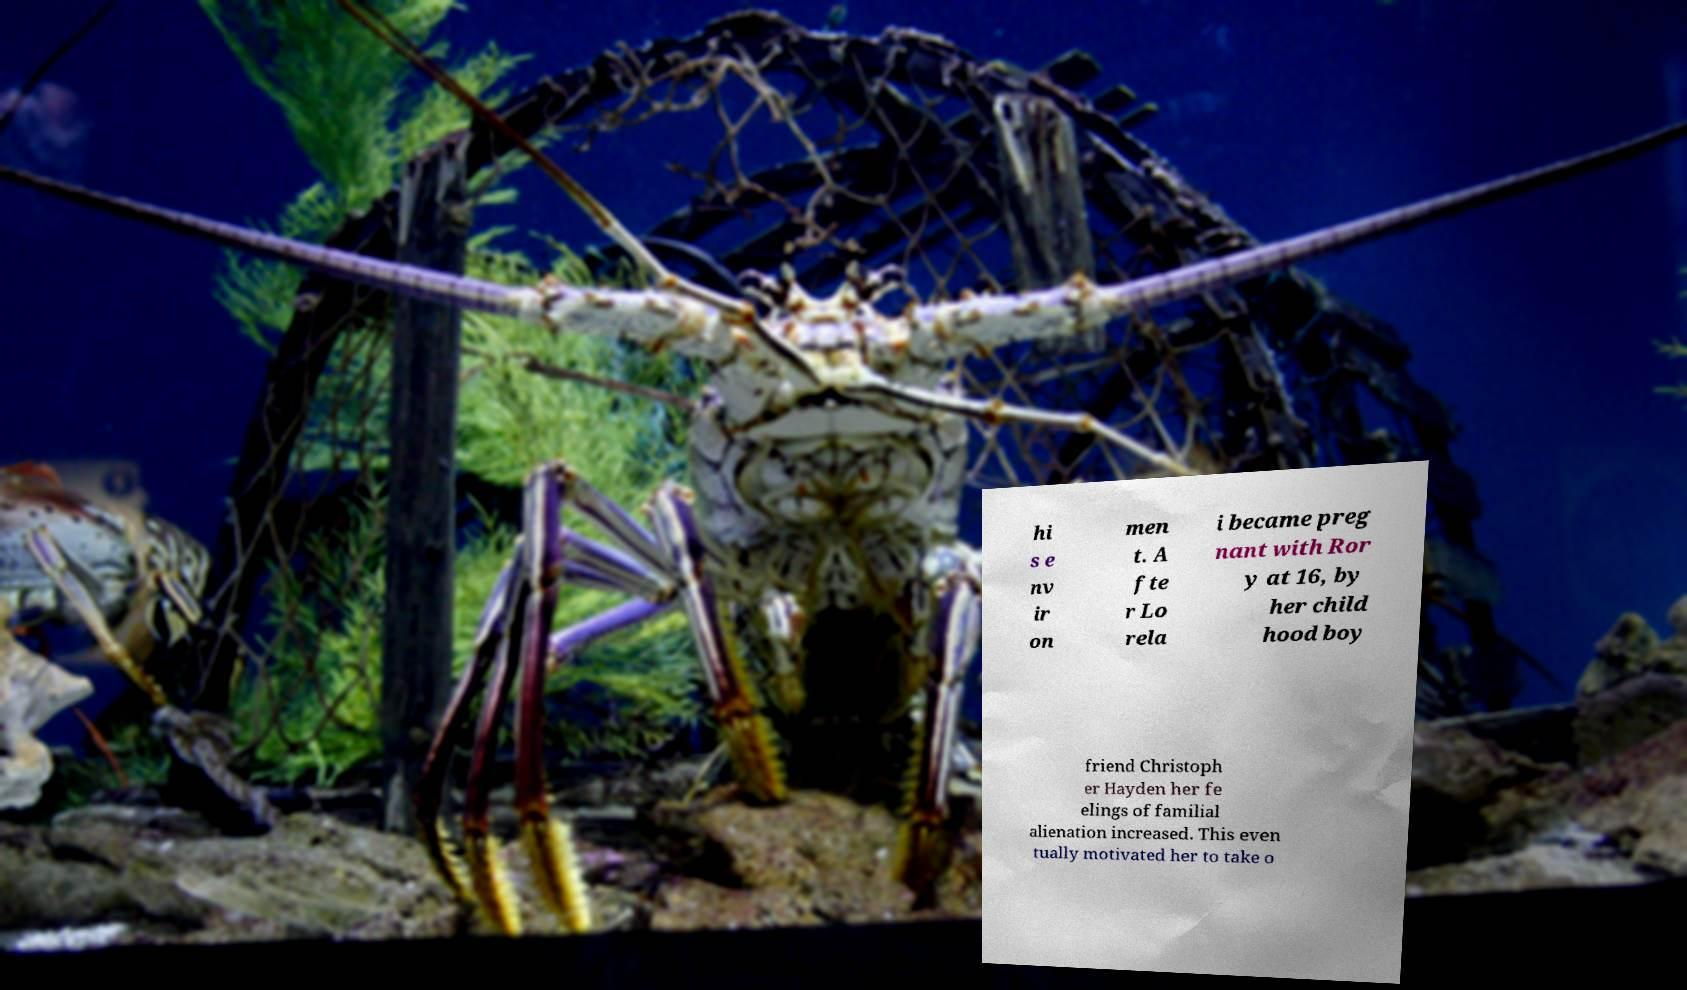I need the written content from this picture converted into text. Can you do that? hi s e nv ir on men t. A fte r Lo rela i became preg nant with Ror y at 16, by her child hood boy friend Christoph er Hayden her fe elings of familial alienation increased. This even tually motivated her to take o 